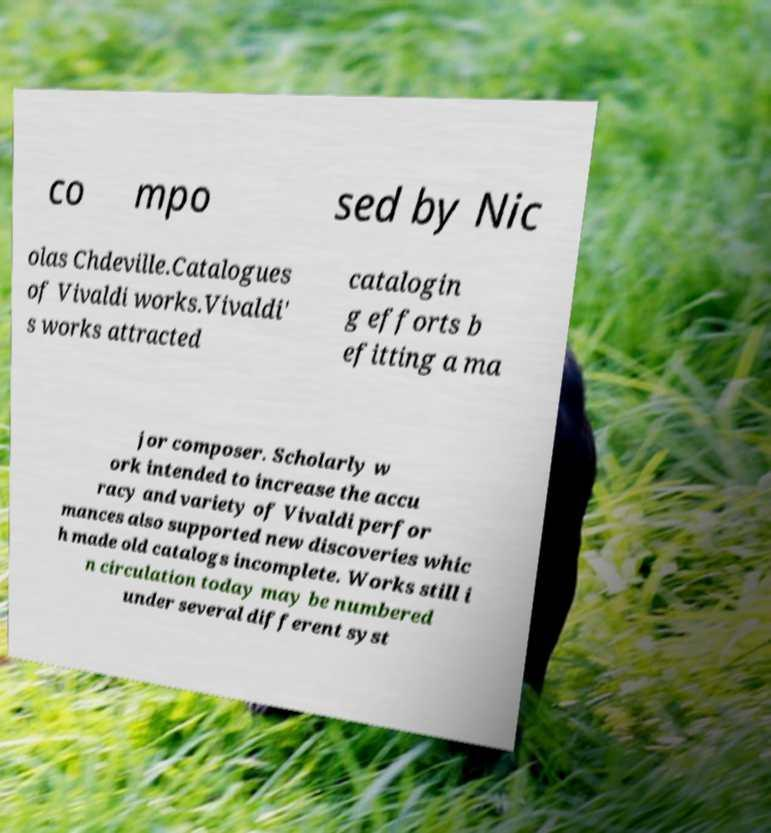What messages or text are displayed in this image? I need them in a readable, typed format. co mpo sed by Nic olas Chdeville.Catalogues of Vivaldi works.Vivaldi' s works attracted catalogin g efforts b efitting a ma jor composer. Scholarly w ork intended to increase the accu racy and variety of Vivaldi perfor mances also supported new discoveries whic h made old catalogs incomplete. Works still i n circulation today may be numbered under several different syst 